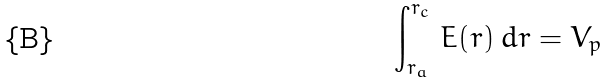<formula> <loc_0><loc_0><loc_500><loc_500>\int _ { r _ { a } } ^ { r _ { c } } \, E ( r ) \, d r = V _ { p }</formula> 